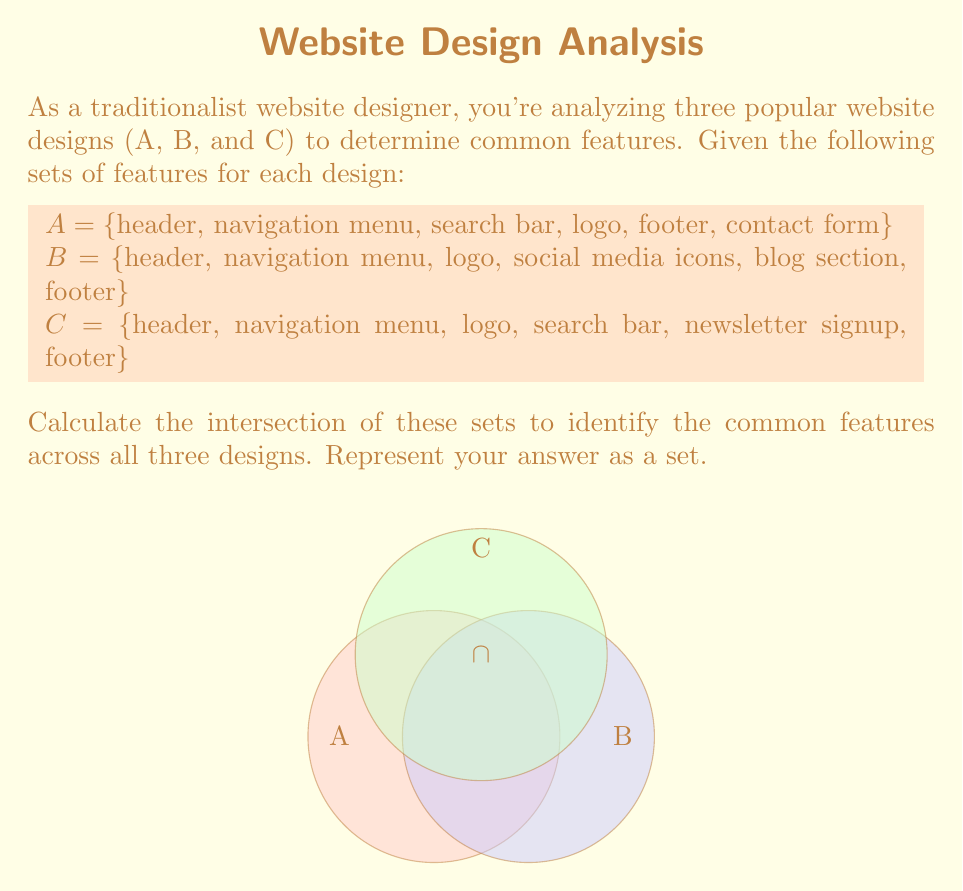Give your solution to this math problem. To find the intersection of sets A, B, and C, we need to identify the elements that are present in all three sets. Let's approach this step-by-step:

1) First, let's list out all the elements in each set:
   A = {header, navigation menu, search bar, logo, footer, contact form}
   B = {header, navigation menu, logo, social media icons, blog section, footer}
   C = {header, navigation menu, logo, search bar, newsletter signup, footer}

2) Now, we need to identify which elements appear in all three sets. We can do this by checking each element:

   - header: present in A, B, and C
   - navigation menu: present in A, B, and C
   - logo: present in A, B, and C
   - footer: present in A, B, and C
   - search bar: present in A and C, but not B
   - contact form: only in A
   - social media icons: only in B
   - blog section: only in B
   - newsletter signup: only in C

3) The elements that appear in all three sets are: header, navigation menu, logo, and footer.

4) We can represent this intersection mathematically as:

   $$A \cap B \cap C = \{header, navigation menu, logo, footer\}$$

This set represents the common features across all three website designs.
Answer: $\{header, navigation menu, logo, footer\}$ 